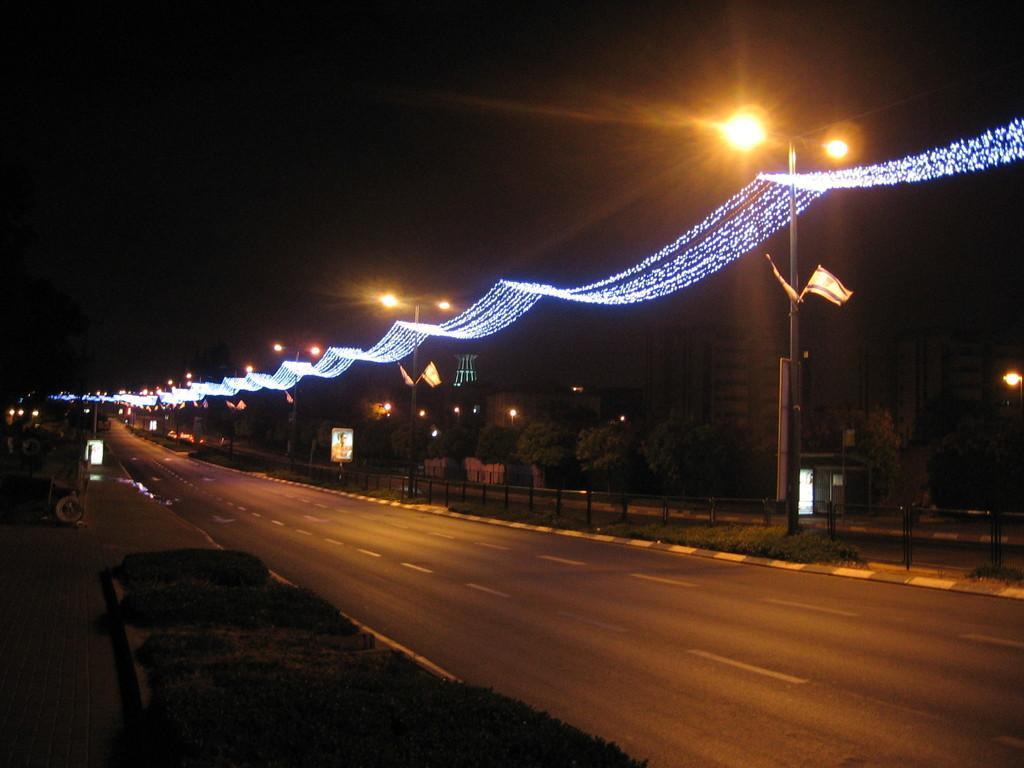Describe this image in one or two sentences. In this image, we can see roads, rods, poles, boards, trees, plants, lights, flags, decorative objects and few things. Background there is a dark view. 